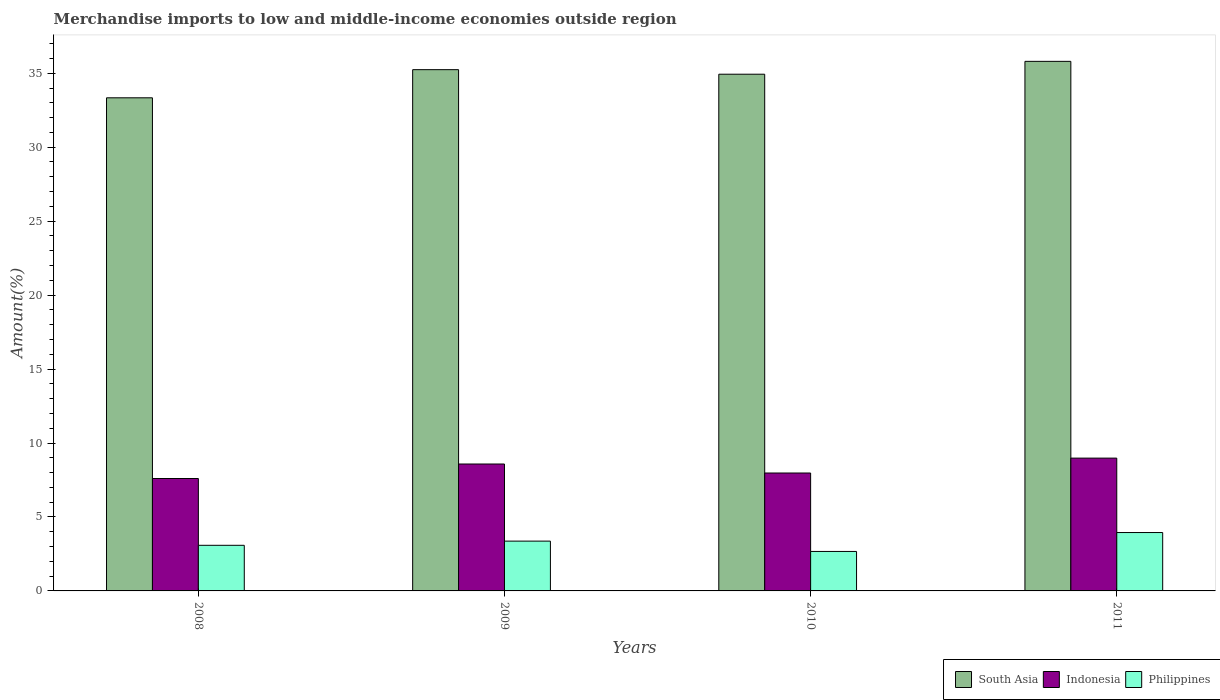How many different coloured bars are there?
Offer a terse response. 3. How many groups of bars are there?
Ensure brevity in your answer.  4. Are the number of bars on each tick of the X-axis equal?
Ensure brevity in your answer.  Yes. How many bars are there on the 2nd tick from the left?
Offer a very short reply. 3. How many bars are there on the 3rd tick from the right?
Your response must be concise. 3. In how many cases, is the number of bars for a given year not equal to the number of legend labels?
Keep it short and to the point. 0. What is the percentage of amount earned from merchandise imports in Philippines in 2011?
Your response must be concise. 3.95. Across all years, what is the maximum percentage of amount earned from merchandise imports in Philippines?
Give a very brief answer. 3.95. Across all years, what is the minimum percentage of amount earned from merchandise imports in South Asia?
Provide a short and direct response. 33.34. In which year was the percentage of amount earned from merchandise imports in Indonesia minimum?
Provide a short and direct response. 2008. What is the total percentage of amount earned from merchandise imports in Philippines in the graph?
Your answer should be very brief. 13.07. What is the difference between the percentage of amount earned from merchandise imports in Philippines in 2008 and that in 2010?
Provide a succinct answer. 0.41. What is the difference between the percentage of amount earned from merchandise imports in Philippines in 2010 and the percentage of amount earned from merchandise imports in Indonesia in 2009?
Your answer should be very brief. -5.91. What is the average percentage of amount earned from merchandise imports in Indonesia per year?
Your answer should be compact. 8.28. In the year 2009, what is the difference between the percentage of amount earned from merchandise imports in Indonesia and percentage of amount earned from merchandise imports in South Asia?
Keep it short and to the point. -26.66. What is the ratio of the percentage of amount earned from merchandise imports in Indonesia in 2009 to that in 2010?
Make the answer very short. 1.08. Is the percentage of amount earned from merchandise imports in Indonesia in 2008 less than that in 2010?
Your response must be concise. Yes. What is the difference between the highest and the second highest percentage of amount earned from merchandise imports in South Asia?
Your answer should be very brief. 0.56. What is the difference between the highest and the lowest percentage of amount earned from merchandise imports in Indonesia?
Your response must be concise. 1.38. Is it the case that in every year, the sum of the percentage of amount earned from merchandise imports in Philippines and percentage of amount earned from merchandise imports in South Asia is greater than the percentage of amount earned from merchandise imports in Indonesia?
Offer a terse response. Yes. How many bars are there?
Provide a short and direct response. 12. Are the values on the major ticks of Y-axis written in scientific E-notation?
Give a very brief answer. No. Does the graph contain any zero values?
Offer a very short reply. No. Does the graph contain grids?
Offer a very short reply. No. How are the legend labels stacked?
Make the answer very short. Horizontal. What is the title of the graph?
Ensure brevity in your answer.  Merchandise imports to low and middle-income economies outside region. Does "Thailand" appear as one of the legend labels in the graph?
Your answer should be compact. No. What is the label or title of the X-axis?
Make the answer very short. Years. What is the label or title of the Y-axis?
Make the answer very short. Amount(%). What is the Amount(%) in South Asia in 2008?
Provide a succinct answer. 33.34. What is the Amount(%) of Indonesia in 2008?
Offer a very short reply. 7.6. What is the Amount(%) of Philippines in 2008?
Make the answer very short. 3.08. What is the Amount(%) of South Asia in 2009?
Give a very brief answer. 35.24. What is the Amount(%) of Indonesia in 2009?
Offer a terse response. 8.58. What is the Amount(%) of Philippines in 2009?
Offer a terse response. 3.37. What is the Amount(%) of South Asia in 2010?
Make the answer very short. 34.93. What is the Amount(%) in Indonesia in 2010?
Provide a succinct answer. 7.97. What is the Amount(%) in Philippines in 2010?
Your answer should be very brief. 2.67. What is the Amount(%) in South Asia in 2011?
Offer a very short reply. 35.8. What is the Amount(%) in Indonesia in 2011?
Provide a short and direct response. 8.98. What is the Amount(%) in Philippines in 2011?
Keep it short and to the point. 3.95. Across all years, what is the maximum Amount(%) of South Asia?
Your response must be concise. 35.8. Across all years, what is the maximum Amount(%) in Indonesia?
Provide a short and direct response. 8.98. Across all years, what is the maximum Amount(%) in Philippines?
Make the answer very short. 3.95. Across all years, what is the minimum Amount(%) in South Asia?
Make the answer very short. 33.34. Across all years, what is the minimum Amount(%) of Indonesia?
Provide a short and direct response. 7.6. Across all years, what is the minimum Amount(%) of Philippines?
Your response must be concise. 2.67. What is the total Amount(%) in South Asia in the graph?
Your answer should be compact. 139.32. What is the total Amount(%) of Indonesia in the graph?
Provide a succinct answer. 33.13. What is the total Amount(%) in Philippines in the graph?
Your answer should be compact. 13.07. What is the difference between the Amount(%) of South Asia in 2008 and that in 2009?
Your response must be concise. -1.9. What is the difference between the Amount(%) of Indonesia in 2008 and that in 2009?
Provide a succinct answer. -0.98. What is the difference between the Amount(%) of Philippines in 2008 and that in 2009?
Your answer should be compact. -0.28. What is the difference between the Amount(%) of South Asia in 2008 and that in 2010?
Ensure brevity in your answer.  -1.6. What is the difference between the Amount(%) in Indonesia in 2008 and that in 2010?
Offer a terse response. -0.37. What is the difference between the Amount(%) of Philippines in 2008 and that in 2010?
Offer a very short reply. 0.41. What is the difference between the Amount(%) in South Asia in 2008 and that in 2011?
Give a very brief answer. -2.46. What is the difference between the Amount(%) of Indonesia in 2008 and that in 2011?
Keep it short and to the point. -1.38. What is the difference between the Amount(%) in Philippines in 2008 and that in 2011?
Offer a very short reply. -0.86. What is the difference between the Amount(%) in South Asia in 2009 and that in 2010?
Make the answer very short. 0.31. What is the difference between the Amount(%) in Indonesia in 2009 and that in 2010?
Provide a short and direct response. 0.61. What is the difference between the Amount(%) in Philippines in 2009 and that in 2010?
Offer a terse response. 0.7. What is the difference between the Amount(%) of South Asia in 2009 and that in 2011?
Give a very brief answer. -0.56. What is the difference between the Amount(%) of Indonesia in 2009 and that in 2011?
Your answer should be compact. -0.4. What is the difference between the Amount(%) of Philippines in 2009 and that in 2011?
Your answer should be compact. -0.58. What is the difference between the Amount(%) of South Asia in 2010 and that in 2011?
Provide a succinct answer. -0.87. What is the difference between the Amount(%) in Indonesia in 2010 and that in 2011?
Give a very brief answer. -1.01. What is the difference between the Amount(%) of Philippines in 2010 and that in 2011?
Your response must be concise. -1.28. What is the difference between the Amount(%) in South Asia in 2008 and the Amount(%) in Indonesia in 2009?
Your answer should be compact. 24.76. What is the difference between the Amount(%) of South Asia in 2008 and the Amount(%) of Philippines in 2009?
Your response must be concise. 29.97. What is the difference between the Amount(%) of Indonesia in 2008 and the Amount(%) of Philippines in 2009?
Your response must be concise. 4.23. What is the difference between the Amount(%) of South Asia in 2008 and the Amount(%) of Indonesia in 2010?
Ensure brevity in your answer.  25.37. What is the difference between the Amount(%) in South Asia in 2008 and the Amount(%) in Philippines in 2010?
Your answer should be very brief. 30.67. What is the difference between the Amount(%) of Indonesia in 2008 and the Amount(%) of Philippines in 2010?
Make the answer very short. 4.93. What is the difference between the Amount(%) of South Asia in 2008 and the Amount(%) of Indonesia in 2011?
Offer a terse response. 24.36. What is the difference between the Amount(%) of South Asia in 2008 and the Amount(%) of Philippines in 2011?
Provide a succinct answer. 29.39. What is the difference between the Amount(%) in Indonesia in 2008 and the Amount(%) in Philippines in 2011?
Your response must be concise. 3.65. What is the difference between the Amount(%) in South Asia in 2009 and the Amount(%) in Indonesia in 2010?
Your answer should be very brief. 27.27. What is the difference between the Amount(%) in South Asia in 2009 and the Amount(%) in Philippines in 2010?
Your response must be concise. 32.57. What is the difference between the Amount(%) in Indonesia in 2009 and the Amount(%) in Philippines in 2010?
Provide a succinct answer. 5.91. What is the difference between the Amount(%) of South Asia in 2009 and the Amount(%) of Indonesia in 2011?
Your answer should be very brief. 26.26. What is the difference between the Amount(%) in South Asia in 2009 and the Amount(%) in Philippines in 2011?
Your response must be concise. 31.29. What is the difference between the Amount(%) in Indonesia in 2009 and the Amount(%) in Philippines in 2011?
Keep it short and to the point. 4.63. What is the difference between the Amount(%) of South Asia in 2010 and the Amount(%) of Indonesia in 2011?
Offer a very short reply. 25.96. What is the difference between the Amount(%) of South Asia in 2010 and the Amount(%) of Philippines in 2011?
Ensure brevity in your answer.  30.99. What is the difference between the Amount(%) in Indonesia in 2010 and the Amount(%) in Philippines in 2011?
Your response must be concise. 4.02. What is the average Amount(%) in South Asia per year?
Your response must be concise. 34.83. What is the average Amount(%) in Indonesia per year?
Ensure brevity in your answer.  8.28. What is the average Amount(%) in Philippines per year?
Offer a terse response. 3.27. In the year 2008, what is the difference between the Amount(%) in South Asia and Amount(%) in Indonesia?
Your response must be concise. 25.74. In the year 2008, what is the difference between the Amount(%) in South Asia and Amount(%) in Philippines?
Your response must be concise. 30.25. In the year 2008, what is the difference between the Amount(%) of Indonesia and Amount(%) of Philippines?
Your answer should be very brief. 4.52. In the year 2009, what is the difference between the Amount(%) of South Asia and Amount(%) of Indonesia?
Your answer should be very brief. 26.66. In the year 2009, what is the difference between the Amount(%) in South Asia and Amount(%) in Philippines?
Make the answer very short. 31.87. In the year 2009, what is the difference between the Amount(%) of Indonesia and Amount(%) of Philippines?
Keep it short and to the point. 5.21. In the year 2010, what is the difference between the Amount(%) in South Asia and Amount(%) in Indonesia?
Offer a very short reply. 26.96. In the year 2010, what is the difference between the Amount(%) in South Asia and Amount(%) in Philippines?
Provide a succinct answer. 32.26. In the year 2010, what is the difference between the Amount(%) of Indonesia and Amount(%) of Philippines?
Give a very brief answer. 5.3. In the year 2011, what is the difference between the Amount(%) in South Asia and Amount(%) in Indonesia?
Your response must be concise. 26.82. In the year 2011, what is the difference between the Amount(%) in South Asia and Amount(%) in Philippines?
Your answer should be compact. 31.86. In the year 2011, what is the difference between the Amount(%) in Indonesia and Amount(%) in Philippines?
Provide a succinct answer. 5.03. What is the ratio of the Amount(%) in South Asia in 2008 to that in 2009?
Your answer should be very brief. 0.95. What is the ratio of the Amount(%) of Indonesia in 2008 to that in 2009?
Ensure brevity in your answer.  0.89. What is the ratio of the Amount(%) in Philippines in 2008 to that in 2009?
Offer a very short reply. 0.92. What is the ratio of the Amount(%) of South Asia in 2008 to that in 2010?
Provide a short and direct response. 0.95. What is the ratio of the Amount(%) in Indonesia in 2008 to that in 2010?
Offer a terse response. 0.95. What is the ratio of the Amount(%) of Philippines in 2008 to that in 2010?
Keep it short and to the point. 1.16. What is the ratio of the Amount(%) of South Asia in 2008 to that in 2011?
Keep it short and to the point. 0.93. What is the ratio of the Amount(%) of Indonesia in 2008 to that in 2011?
Provide a short and direct response. 0.85. What is the ratio of the Amount(%) of Philippines in 2008 to that in 2011?
Provide a short and direct response. 0.78. What is the ratio of the Amount(%) of South Asia in 2009 to that in 2010?
Keep it short and to the point. 1.01. What is the ratio of the Amount(%) of Indonesia in 2009 to that in 2010?
Keep it short and to the point. 1.08. What is the ratio of the Amount(%) in Philippines in 2009 to that in 2010?
Your response must be concise. 1.26. What is the ratio of the Amount(%) of South Asia in 2009 to that in 2011?
Provide a short and direct response. 0.98. What is the ratio of the Amount(%) in Indonesia in 2009 to that in 2011?
Your answer should be very brief. 0.96. What is the ratio of the Amount(%) in Philippines in 2009 to that in 2011?
Provide a short and direct response. 0.85. What is the ratio of the Amount(%) in South Asia in 2010 to that in 2011?
Offer a terse response. 0.98. What is the ratio of the Amount(%) in Indonesia in 2010 to that in 2011?
Offer a very short reply. 0.89. What is the ratio of the Amount(%) of Philippines in 2010 to that in 2011?
Provide a short and direct response. 0.68. What is the difference between the highest and the second highest Amount(%) in South Asia?
Provide a short and direct response. 0.56. What is the difference between the highest and the second highest Amount(%) of Indonesia?
Your answer should be very brief. 0.4. What is the difference between the highest and the second highest Amount(%) in Philippines?
Your answer should be very brief. 0.58. What is the difference between the highest and the lowest Amount(%) of South Asia?
Ensure brevity in your answer.  2.46. What is the difference between the highest and the lowest Amount(%) of Indonesia?
Provide a succinct answer. 1.38. What is the difference between the highest and the lowest Amount(%) of Philippines?
Provide a succinct answer. 1.28. 